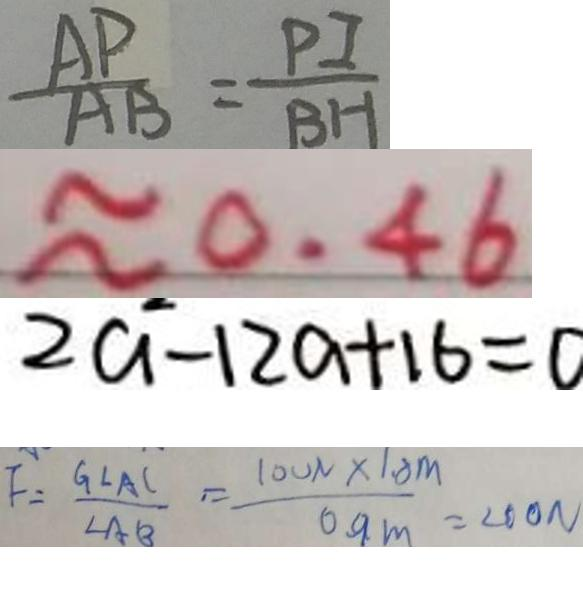<formula> <loc_0><loc_0><loc_500><loc_500>\frac { A P } { A B } = \frac { P I } { B H } 
 \approx 0 . 4 6 
 2 a - 1 2 a + 1 6 = 0 
 F = \frac { G \angle A C } { \angle A B } = \frac { 1 0 0 N \times 1 . 8 m } { 0 . 9 m } = 2 0 0 N</formula> 